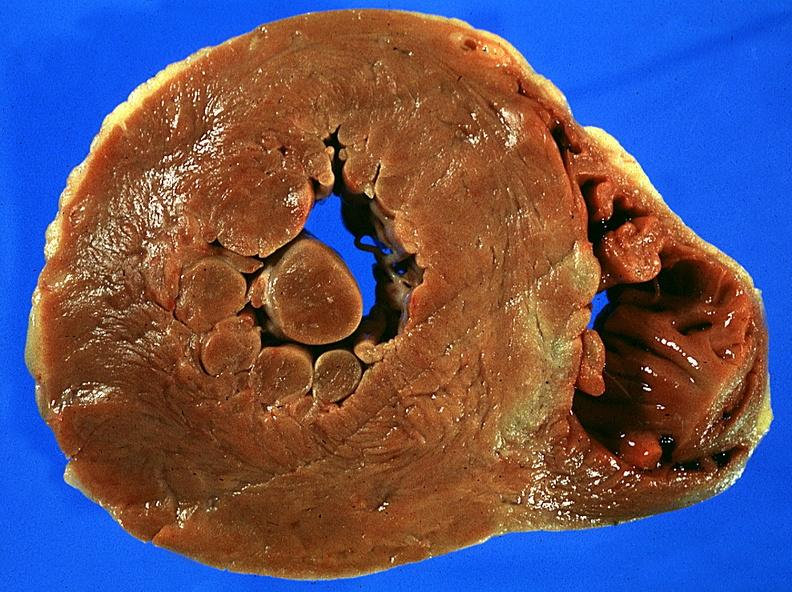what does this image show?
Answer the question using a single word or phrase. Left ventricular hypertrophy 